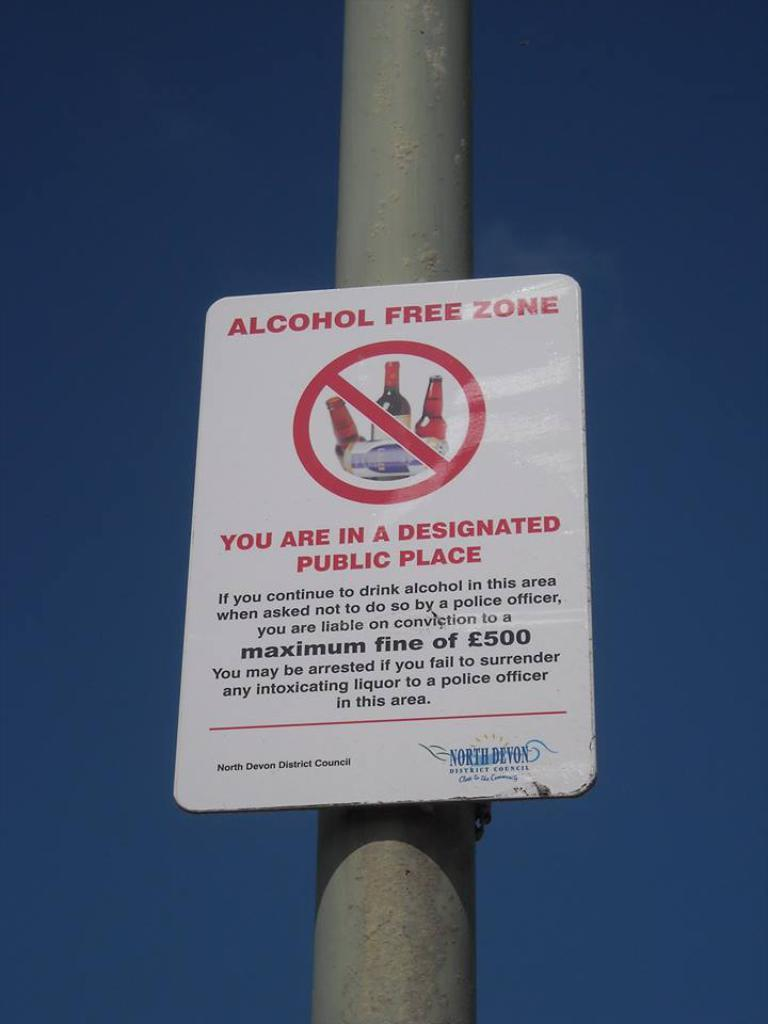<image>
Share a concise interpretation of the image provided. A sign alerts people to the presence of an alcohol free zone. 